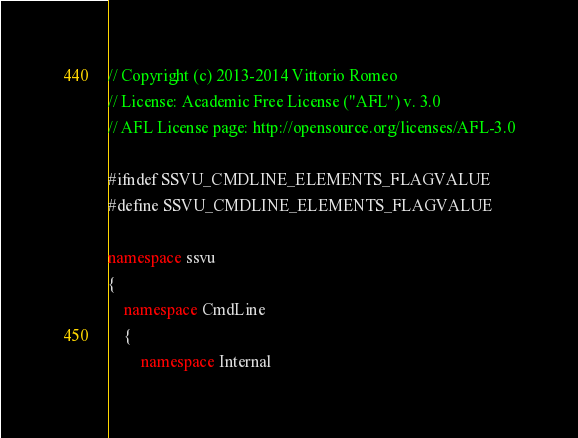<code> <loc_0><loc_0><loc_500><loc_500><_C++_>// Copyright (c) 2013-2014 Vittorio Romeo
// License: Academic Free License ("AFL") v. 3.0
// AFL License page: http://opensource.org/licenses/AFL-3.0

#ifndef SSVU_CMDLINE_ELEMENTS_FLAGVALUE
#define SSVU_CMDLINE_ELEMENTS_FLAGVALUE

namespace ssvu
{
	namespace CmdLine
	{
		namespace Internal</code> 